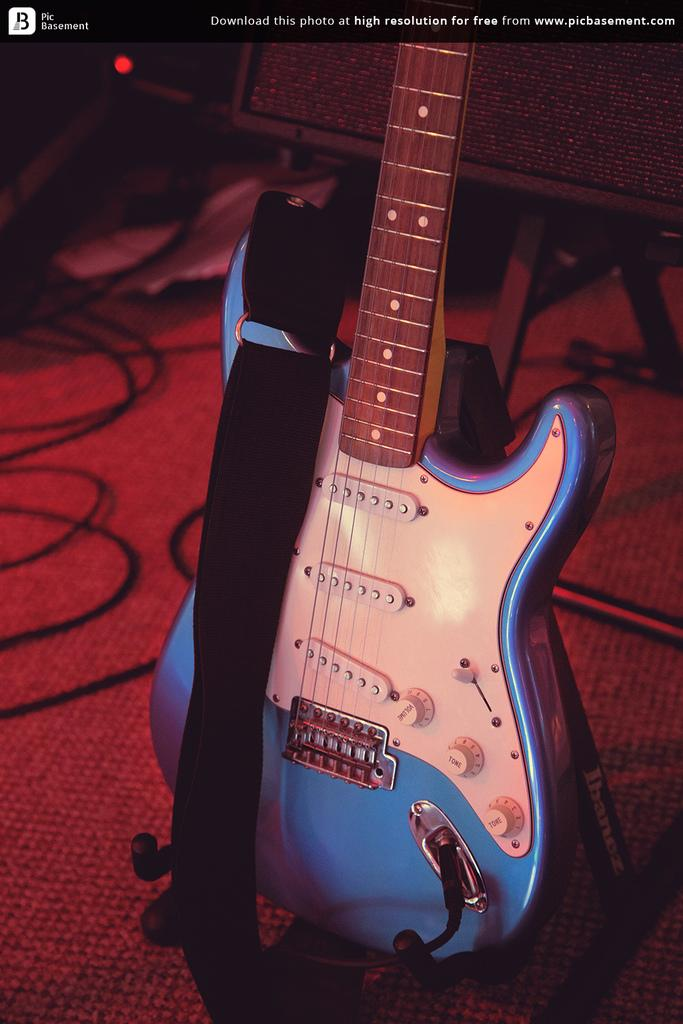What musical instrument is in the image? There is a guitar in the image. Where is the guitar located? The guitar is on the floor. What else can be seen in the image besides the guitar? Cables are visible in the image. How many seeds can be seen on the guitar in the image? There are no seeds present on the guitar in the image. Can you touch the zipper on the guitar in the image? There is no zipper on the guitar in the image. 